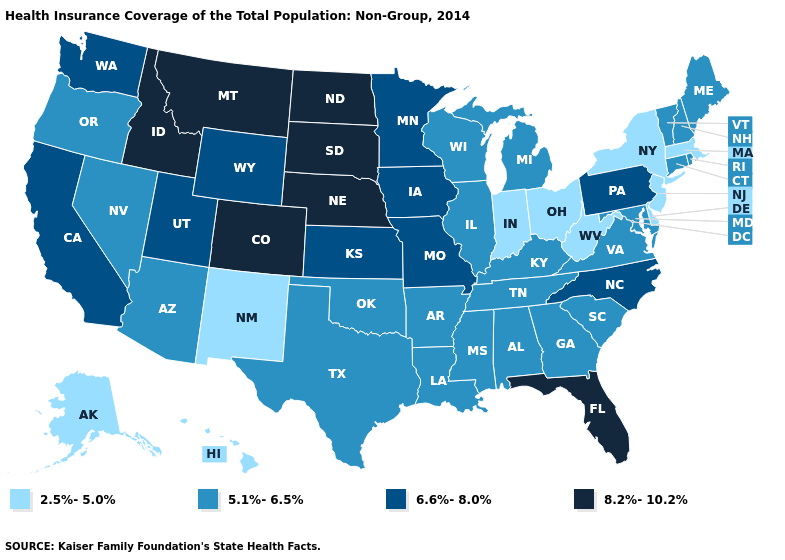Which states have the lowest value in the USA?
Give a very brief answer. Alaska, Delaware, Hawaii, Indiana, Massachusetts, New Jersey, New Mexico, New York, Ohio, West Virginia. What is the highest value in states that border South Dakota?
Quick response, please. 8.2%-10.2%. Which states have the lowest value in the USA?
Answer briefly. Alaska, Delaware, Hawaii, Indiana, Massachusetts, New Jersey, New Mexico, New York, Ohio, West Virginia. Does South Dakota have the highest value in the USA?
Short answer required. Yes. Name the states that have a value in the range 5.1%-6.5%?
Give a very brief answer. Alabama, Arizona, Arkansas, Connecticut, Georgia, Illinois, Kentucky, Louisiana, Maine, Maryland, Michigan, Mississippi, Nevada, New Hampshire, Oklahoma, Oregon, Rhode Island, South Carolina, Tennessee, Texas, Vermont, Virginia, Wisconsin. How many symbols are there in the legend?
Keep it brief. 4. What is the highest value in the MidWest ?
Give a very brief answer. 8.2%-10.2%. Name the states that have a value in the range 8.2%-10.2%?
Answer briefly. Colorado, Florida, Idaho, Montana, Nebraska, North Dakota, South Dakota. Does Pennsylvania have the highest value in the Northeast?
Write a very short answer. Yes. What is the highest value in the USA?
Be succinct. 8.2%-10.2%. Does Idaho have a higher value than South Carolina?
Give a very brief answer. Yes. Which states have the highest value in the USA?
Keep it brief. Colorado, Florida, Idaho, Montana, Nebraska, North Dakota, South Dakota. Does Vermont have a lower value than Rhode Island?
Answer briefly. No. What is the value of Indiana?
Keep it brief. 2.5%-5.0%. What is the value of North Carolina?
Answer briefly. 6.6%-8.0%. 